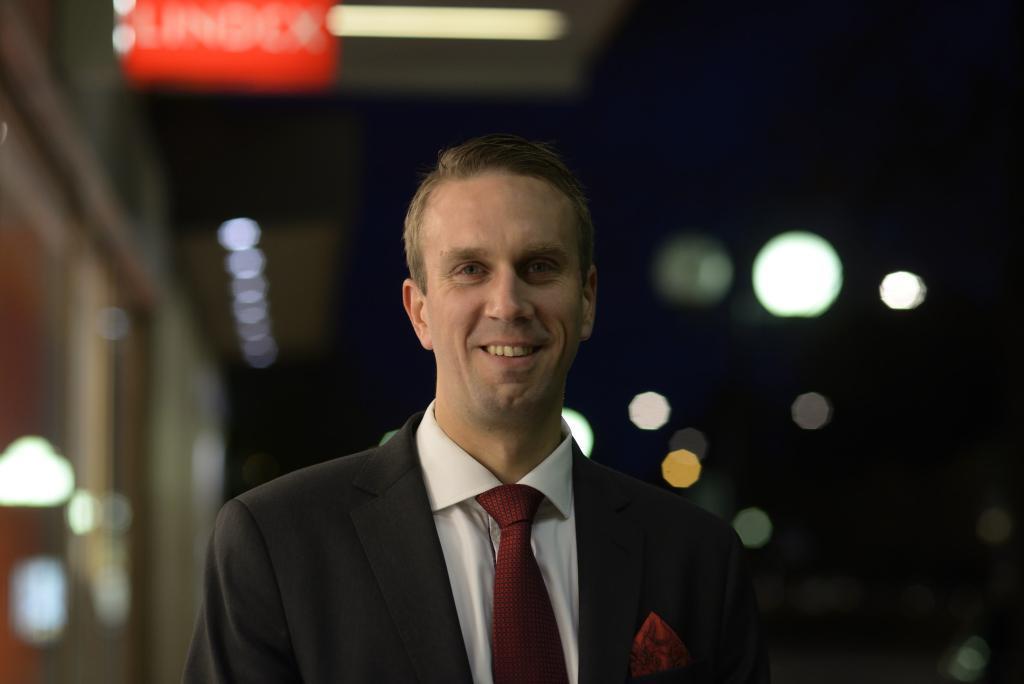In one or two sentences, can you explain what this image depicts? In the image we can see a man wearing a blazer, shirt, tie and he is smiling. Here we can see the lights and the background is blurred. 